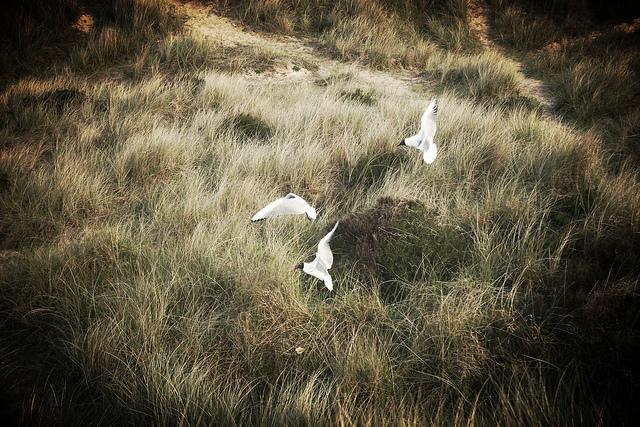What caused this oil spill?
Answer briefly. People. What color is the animal?
Give a very brief answer. White. Does the bird have smooth feathers?
Keep it brief. Yes. What land formations are shown in the image?
Answer briefly. Hills. What color is the bird?
Quick response, please. White. What color are the birds?
Answer briefly. White. What are the birds flying over?
Answer briefly. Grass. What animal is in the photo?
Quick response, please. Birds. Is the bird flying?
Give a very brief answer. Yes. How many birds are pictured?
Keep it brief. 3. How many birds?
Be succinct. 3. What animal is in the picture?
Write a very short answer. Birds. What type of birds are these?
Write a very short answer. Seagulls. Does this seem cute?
Write a very short answer. No. 